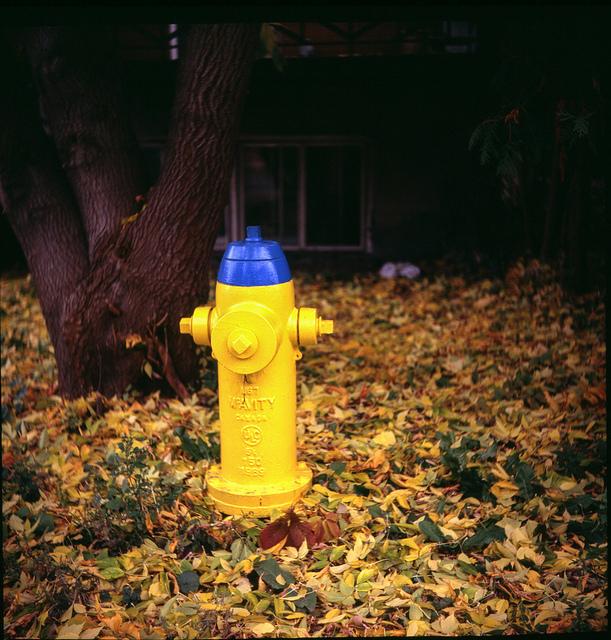What color is the trunk?
Answer briefly. Brown. Is the fire hydrant at the curb?
Quick response, please. No. What size is the valve?
Give a very brief answer. 2 inch. What season is this?
Be succinct. Fall. In how many colors is the fire hydrant painted?
Answer briefly. 2. 